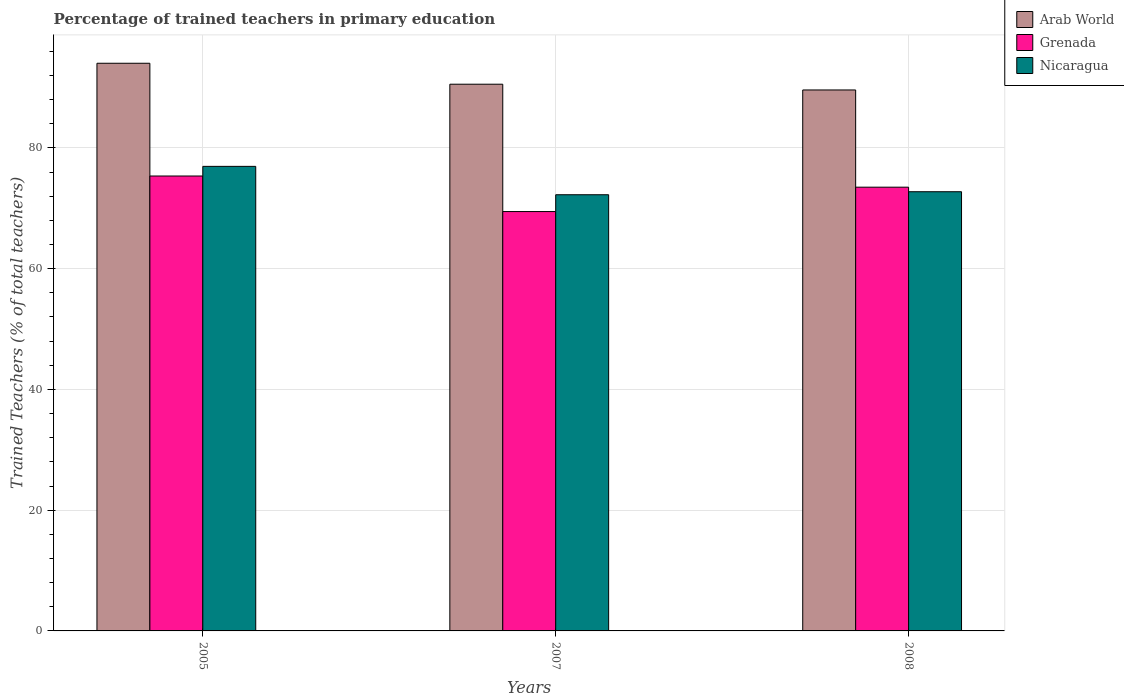How many different coloured bars are there?
Ensure brevity in your answer.  3. How many groups of bars are there?
Provide a short and direct response. 3. How many bars are there on the 3rd tick from the right?
Your answer should be compact. 3. What is the percentage of trained teachers in Grenada in 2005?
Offer a terse response. 75.35. Across all years, what is the maximum percentage of trained teachers in Nicaragua?
Offer a terse response. 76.94. Across all years, what is the minimum percentage of trained teachers in Nicaragua?
Your answer should be compact. 72.25. In which year was the percentage of trained teachers in Arab World maximum?
Offer a very short reply. 2005. What is the total percentage of trained teachers in Arab World in the graph?
Offer a very short reply. 274.17. What is the difference between the percentage of trained teachers in Nicaragua in 2005 and that in 2007?
Provide a succinct answer. 4.7. What is the difference between the percentage of trained teachers in Nicaragua in 2007 and the percentage of trained teachers in Grenada in 2008?
Offer a very short reply. -1.25. What is the average percentage of trained teachers in Nicaragua per year?
Your answer should be very brief. 73.98. In the year 2007, what is the difference between the percentage of trained teachers in Grenada and percentage of trained teachers in Arab World?
Make the answer very short. -21.09. What is the ratio of the percentage of trained teachers in Arab World in 2005 to that in 2007?
Offer a terse response. 1.04. Is the percentage of trained teachers in Arab World in 2005 less than that in 2007?
Your answer should be compact. No. What is the difference between the highest and the second highest percentage of trained teachers in Nicaragua?
Ensure brevity in your answer.  4.2. What is the difference between the highest and the lowest percentage of trained teachers in Arab World?
Offer a terse response. 4.42. Is the sum of the percentage of trained teachers in Grenada in 2007 and 2008 greater than the maximum percentage of trained teachers in Nicaragua across all years?
Your answer should be very brief. Yes. What does the 3rd bar from the left in 2005 represents?
Your answer should be compact. Nicaragua. What does the 3rd bar from the right in 2007 represents?
Your answer should be compact. Arab World. Is it the case that in every year, the sum of the percentage of trained teachers in Arab World and percentage of trained teachers in Grenada is greater than the percentage of trained teachers in Nicaragua?
Keep it short and to the point. Yes. How many bars are there?
Keep it short and to the point. 9. Are the values on the major ticks of Y-axis written in scientific E-notation?
Your response must be concise. No. Does the graph contain any zero values?
Offer a terse response. No. Does the graph contain grids?
Keep it short and to the point. Yes. Where does the legend appear in the graph?
Offer a terse response. Top right. What is the title of the graph?
Offer a very short reply. Percentage of trained teachers in primary education. What is the label or title of the Y-axis?
Your answer should be compact. Trained Teachers (% of total teachers). What is the Trained Teachers (% of total teachers) in Arab World in 2005?
Offer a very short reply. 94.02. What is the Trained Teachers (% of total teachers) in Grenada in 2005?
Offer a very short reply. 75.35. What is the Trained Teachers (% of total teachers) of Nicaragua in 2005?
Provide a short and direct response. 76.94. What is the Trained Teachers (% of total teachers) of Arab World in 2007?
Keep it short and to the point. 90.55. What is the Trained Teachers (% of total teachers) of Grenada in 2007?
Offer a terse response. 69.46. What is the Trained Teachers (% of total teachers) of Nicaragua in 2007?
Offer a terse response. 72.25. What is the Trained Teachers (% of total teachers) of Arab World in 2008?
Your response must be concise. 89.6. What is the Trained Teachers (% of total teachers) in Grenada in 2008?
Your answer should be compact. 73.5. What is the Trained Teachers (% of total teachers) of Nicaragua in 2008?
Keep it short and to the point. 72.74. Across all years, what is the maximum Trained Teachers (% of total teachers) of Arab World?
Your answer should be very brief. 94.02. Across all years, what is the maximum Trained Teachers (% of total teachers) of Grenada?
Your answer should be compact. 75.35. Across all years, what is the maximum Trained Teachers (% of total teachers) in Nicaragua?
Offer a terse response. 76.94. Across all years, what is the minimum Trained Teachers (% of total teachers) of Arab World?
Give a very brief answer. 89.6. Across all years, what is the minimum Trained Teachers (% of total teachers) in Grenada?
Keep it short and to the point. 69.46. Across all years, what is the minimum Trained Teachers (% of total teachers) of Nicaragua?
Provide a succinct answer. 72.25. What is the total Trained Teachers (% of total teachers) in Arab World in the graph?
Make the answer very short. 274.17. What is the total Trained Teachers (% of total teachers) in Grenada in the graph?
Offer a very short reply. 218.3. What is the total Trained Teachers (% of total teachers) of Nicaragua in the graph?
Your answer should be very brief. 221.93. What is the difference between the Trained Teachers (% of total teachers) in Arab World in 2005 and that in 2007?
Provide a succinct answer. 3.47. What is the difference between the Trained Teachers (% of total teachers) of Grenada in 2005 and that in 2007?
Your answer should be very brief. 5.89. What is the difference between the Trained Teachers (% of total teachers) in Nicaragua in 2005 and that in 2007?
Offer a very short reply. 4.7. What is the difference between the Trained Teachers (% of total teachers) in Arab World in 2005 and that in 2008?
Offer a very short reply. 4.42. What is the difference between the Trained Teachers (% of total teachers) of Grenada in 2005 and that in 2008?
Your answer should be compact. 1.85. What is the difference between the Trained Teachers (% of total teachers) in Nicaragua in 2005 and that in 2008?
Provide a succinct answer. 4.2. What is the difference between the Trained Teachers (% of total teachers) of Arab World in 2007 and that in 2008?
Offer a terse response. 0.95. What is the difference between the Trained Teachers (% of total teachers) of Grenada in 2007 and that in 2008?
Offer a very short reply. -4.04. What is the difference between the Trained Teachers (% of total teachers) of Nicaragua in 2007 and that in 2008?
Provide a succinct answer. -0.5. What is the difference between the Trained Teachers (% of total teachers) in Arab World in 2005 and the Trained Teachers (% of total teachers) in Grenada in 2007?
Make the answer very short. 24.56. What is the difference between the Trained Teachers (% of total teachers) of Arab World in 2005 and the Trained Teachers (% of total teachers) of Nicaragua in 2007?
Your response must be concise. 21.78. What is the difference between the Trained Teachers (% of total teachers) in Grenada in 2005 and the Trained Teachers (% of total teachers) in Nicaragua in 2007?
Make the answer very short. 3.1. What is the difference between the Trained Teachers (% of total teachers) in Arab World in 2005 and the Trained Teachers (% of total teachers) in Grenada in 2008?
Your answer should be very brief. 20.53. What is the difference between the Trained Teachers (% of total teachers) of Arab World in 2005 and the Trained Teachers (% of total teachers) of Nicaragua in 2008?
Your answer should be very brief. 21.28. What is the difference between the Trained Teachers (% of total teachers) in Grenada in 2005 and the Trained Teachers (% of total teachers) in Nicaragua in 2008?
Your answer should be compact. 2.6. What is the difference between the Trained Teachers (% of total teachers) in Arab World in 2007 and the Trained Teachers (% of total teachers) in Grenada in 2008?
Your answer should be compact. 17.06. What is the difference between the Trained Teachers (% of total teachers) in Arab World in 2007 and the Trained Teachers (% of total teachers) in Nicaragua in 2008?
Give a very brief answer. 17.81. What is the difference between the Trained Teachers (% of total teachers) in Grenada in 2007 and the Trained Teachers (% of total teachers) in Nicaragua in 2008?
Your answer should be very brief. -3.28. What is the average Trained Teachers (% of total teachers) of Arab World per year?
Ensure brevity in your answer.  91.39. What is the average Trained Teachers (% of total teachers) in Grenada per year?
Your answer should be compact. 72.77. What is the average Trained Teachers (% of total teachers) of Nicaragua per year?
Your answer should be very brief. 73.98. In the year 2005, what is the difference between the Trained Teachers (% of total teachers) in Arab World and Trained Teachers (% of total teachers) in Grenada?
Offer a terse response. 18.67. In the year 2005, what is the difference between the Trained Teachers (% of total teachers) in Arab World and Trained Teachers (% of total teachers) in Nicaragua?
Your response must be concise. 17.08. In the year 2005, what is the difference between the Trained Teachers (% of total teachers) of Grenada and Trained Teachers (% of total teachers) of Nicaragua?
Provide a succinct answer. -1.6. In the year 2007, what is the difference between the Trained Teachers (% of total teachers) in Arab World and Trained Teachers (% of total teachers) in Grenada?
Offer a terse response. 21.09. In the year 2007, what is the difference between the Trained Teachers (% of total teachers) in Arab World and Trained Teachers (% of total teachers) in Nicaragua?
Offer a very short reply. 18.31. In the year 2007, what is the difference between the Trained Teachers (% of total teachers) of Grenada and Trained Teachers (% of total teachers) of Nicaragua?
Your answer should be compact. -2.79. In the year 2008, what is the difference between the Trained Teachers (% of total teachers) of Arab World and Trained Teachers (% of total teachers) of Grenada?
Offer a terse response. 16.1. In the year 2008, what is the difference between the Trained Teachers (% of total teachers) in Arab World and Trained Teachers (% of total teachers) in Nicaragua?
Your answer should be very brief. 16.86. In the year 2008, what is the difference between the Trained Teachers (% of total teachers) of Grenada and Trained Teachers (% of total teachers) of Nicaragua?
Your answer should be compact. 0.75. What is the ratio of the Trained Teachers (% of total teachers) in Arab World in 2005 to that in 2007?
Keep it short and to the point. 1.04. What is the ratio of the Trained Teachers (% of total teachers) of Grenada in 2005 to that in 2007?
Your answer should be compact. 1.08. What is the ratio of the Trained Teachers (% of total teachers) in Nicaragua in 2005 to that in 2007?
Keep it short and to the point. 1.06. What is the ratio of the Trained Teachers (% of total teachers) in Arab World in 2005 to that in 2008?
Provide a short and direct response. 1.05. What is the ratio of the Trained Teachers (% of total teachers) in Grenada in 2005 to that in 2008?
Your answer should be very brief. 1.03. What is the ratio of the Trained Teachers (% of total teachers) of Nicaragua in 2005 to that in 2008?
Provide a short and direct response. 1.06. What is the ratio of the Trained Teachers (% of total teachers) in Arab World in 2007 to that in 2008?
Offer a terse response. 1.01. What is the ratio of the Trained Teachers (% of total teachers) of Grenada in 2007 to that in 2008?
Ensure brevity in your answer.  0.95. What is the ratio of the Trained Teachers (% of total teachers) of Nicaragua in 2007 to that in 2008?
Make the answer very short. 0.99. What is the difference between the highest and the second highest Trained Teachers (% of total teachers) of Arab World?
Offer a terse response. 3.47. What is the difference between the highest and the second highest Trained Teachers (% of total teachers) in Grenada?
Ensure brevity in your answer.  1.85. What is the difference between the highest and the second highest Trained Teachers (% of total teachers) of Nicaragua?
Offer a very short reply. 4.2. What is the difference between the highest and the lowest Trained Teachers (% of total teachers) in Arab World?
Your answer should be very brief. 4.42. What is the difference between the highest and the lowest Trained Teachers (% of total teachers) in Grenada?
Your answer should be compact. 5.89. What is the difference between the highest and the lowest Trained Teachers (% of total teachers) of Nicaragua?
Provide a short and direct response. 4.7. 